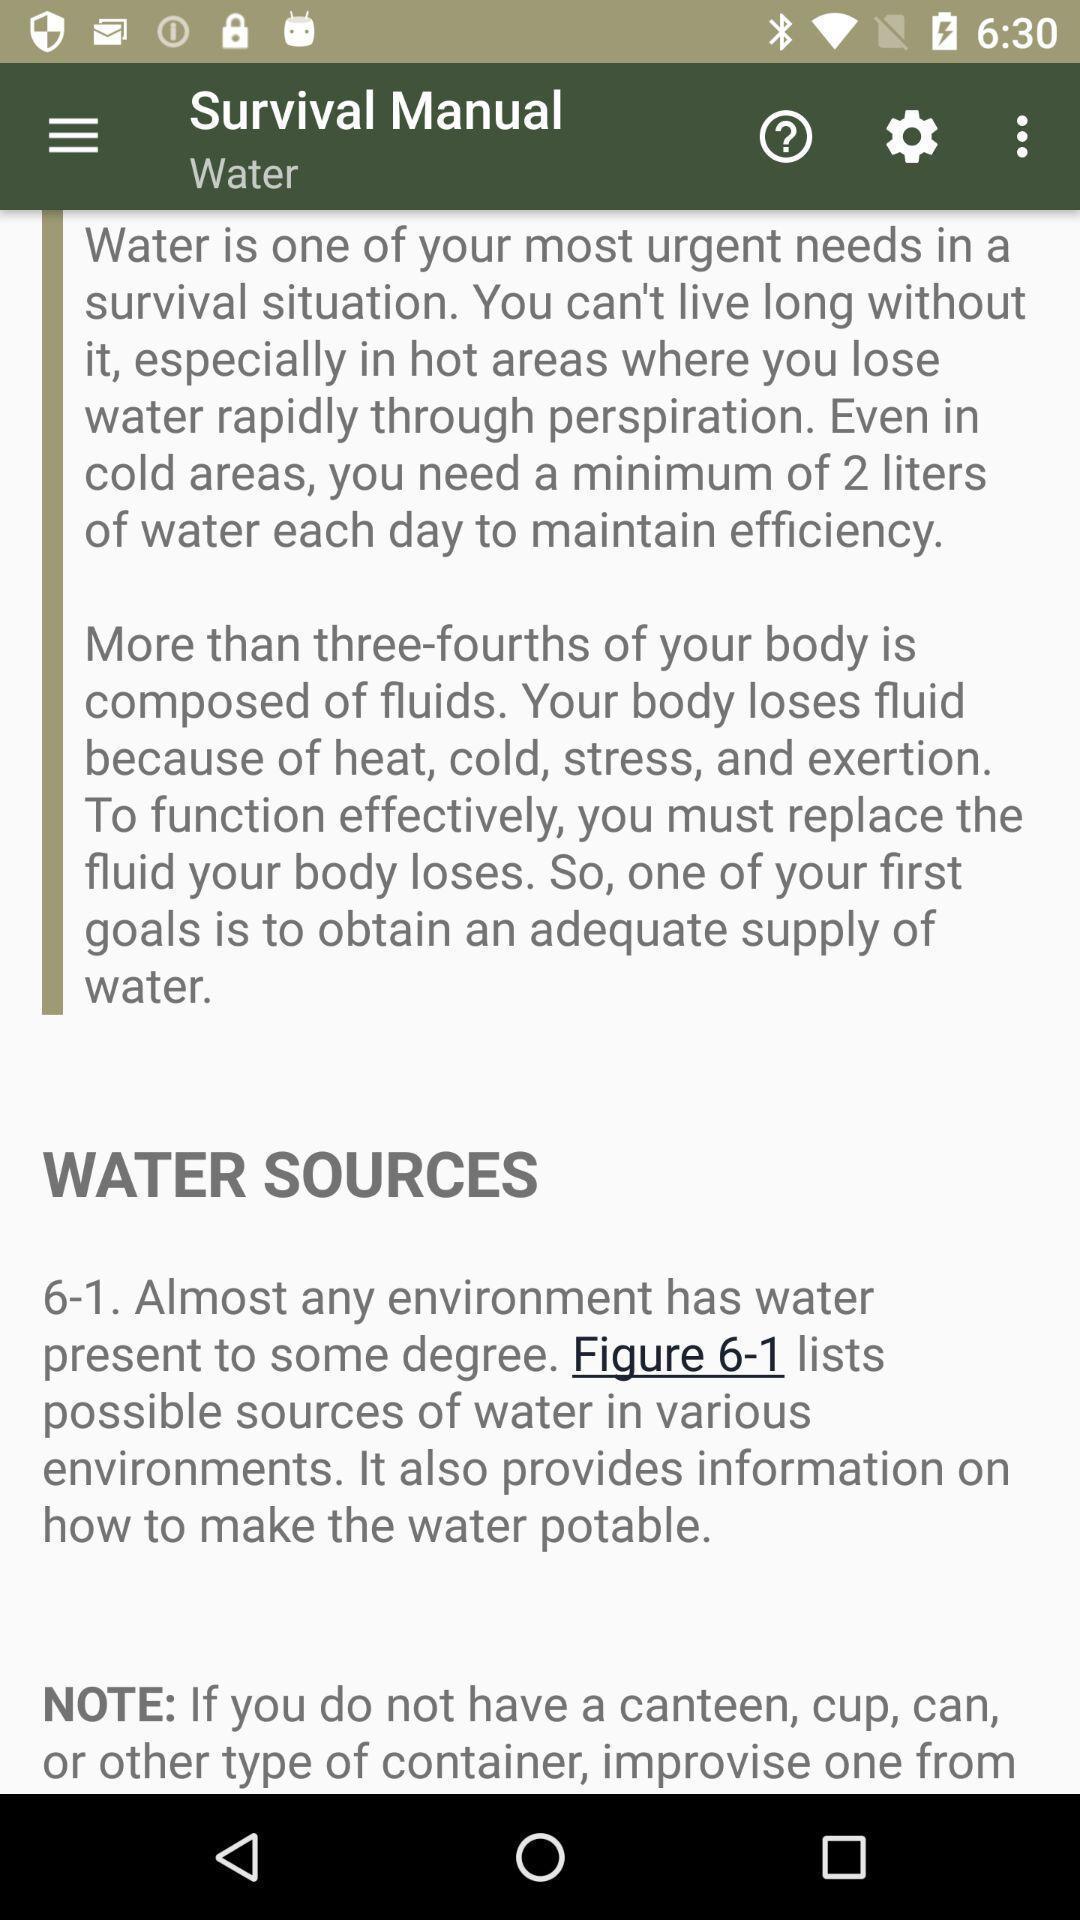Tell me about the visual elements in this screen capture. Screen showing water sources in application. 